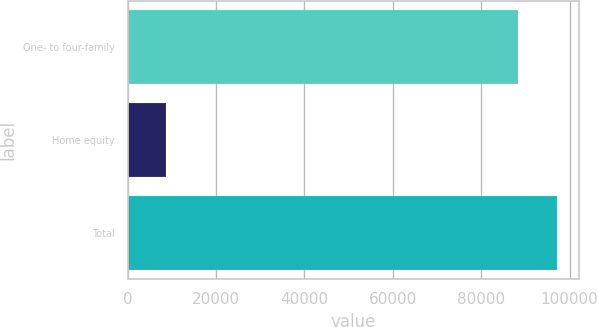Convert chart to OTSL. <chart><loc_0><loc_0><loc_500><loc_500><bar_chart><fcel>One- to four-family<fcel>Home equity<fcel>Total<nl><fcel>88347<fcel>8645<fcel>97181.7<nl></chart> 